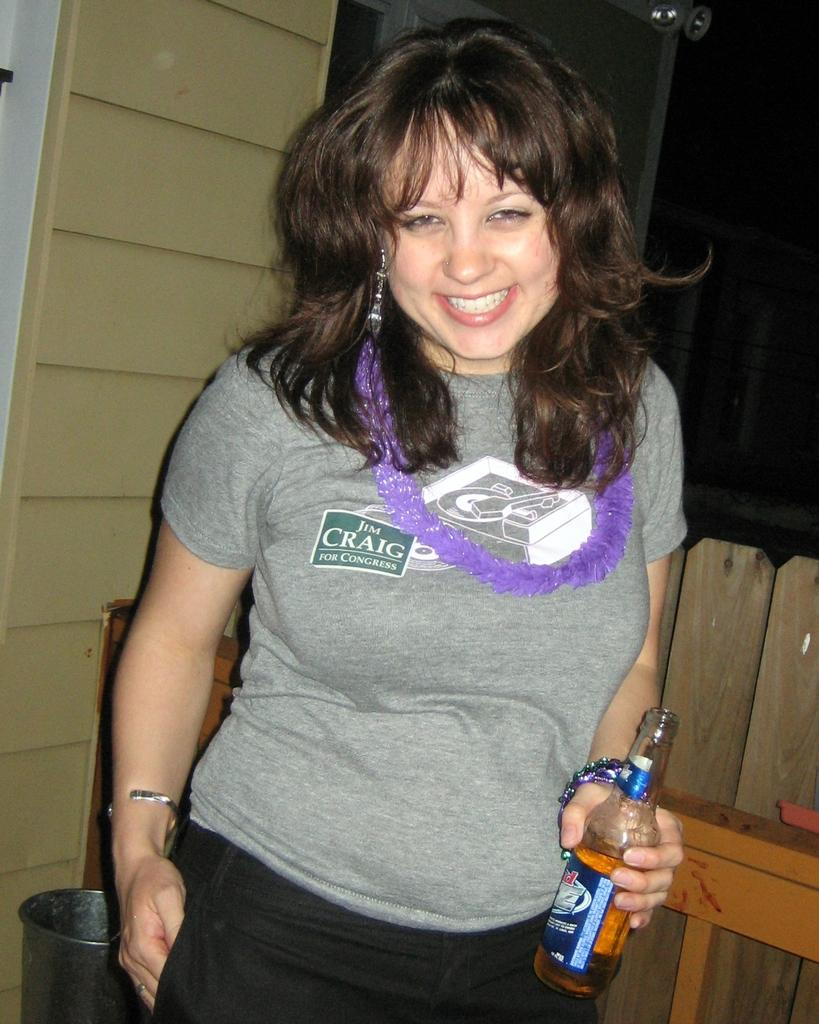<image>
Write a terse but informative summary of the picture. A woman is smiling and drinking a beer and her shirt says Jim Craig for Congress. 